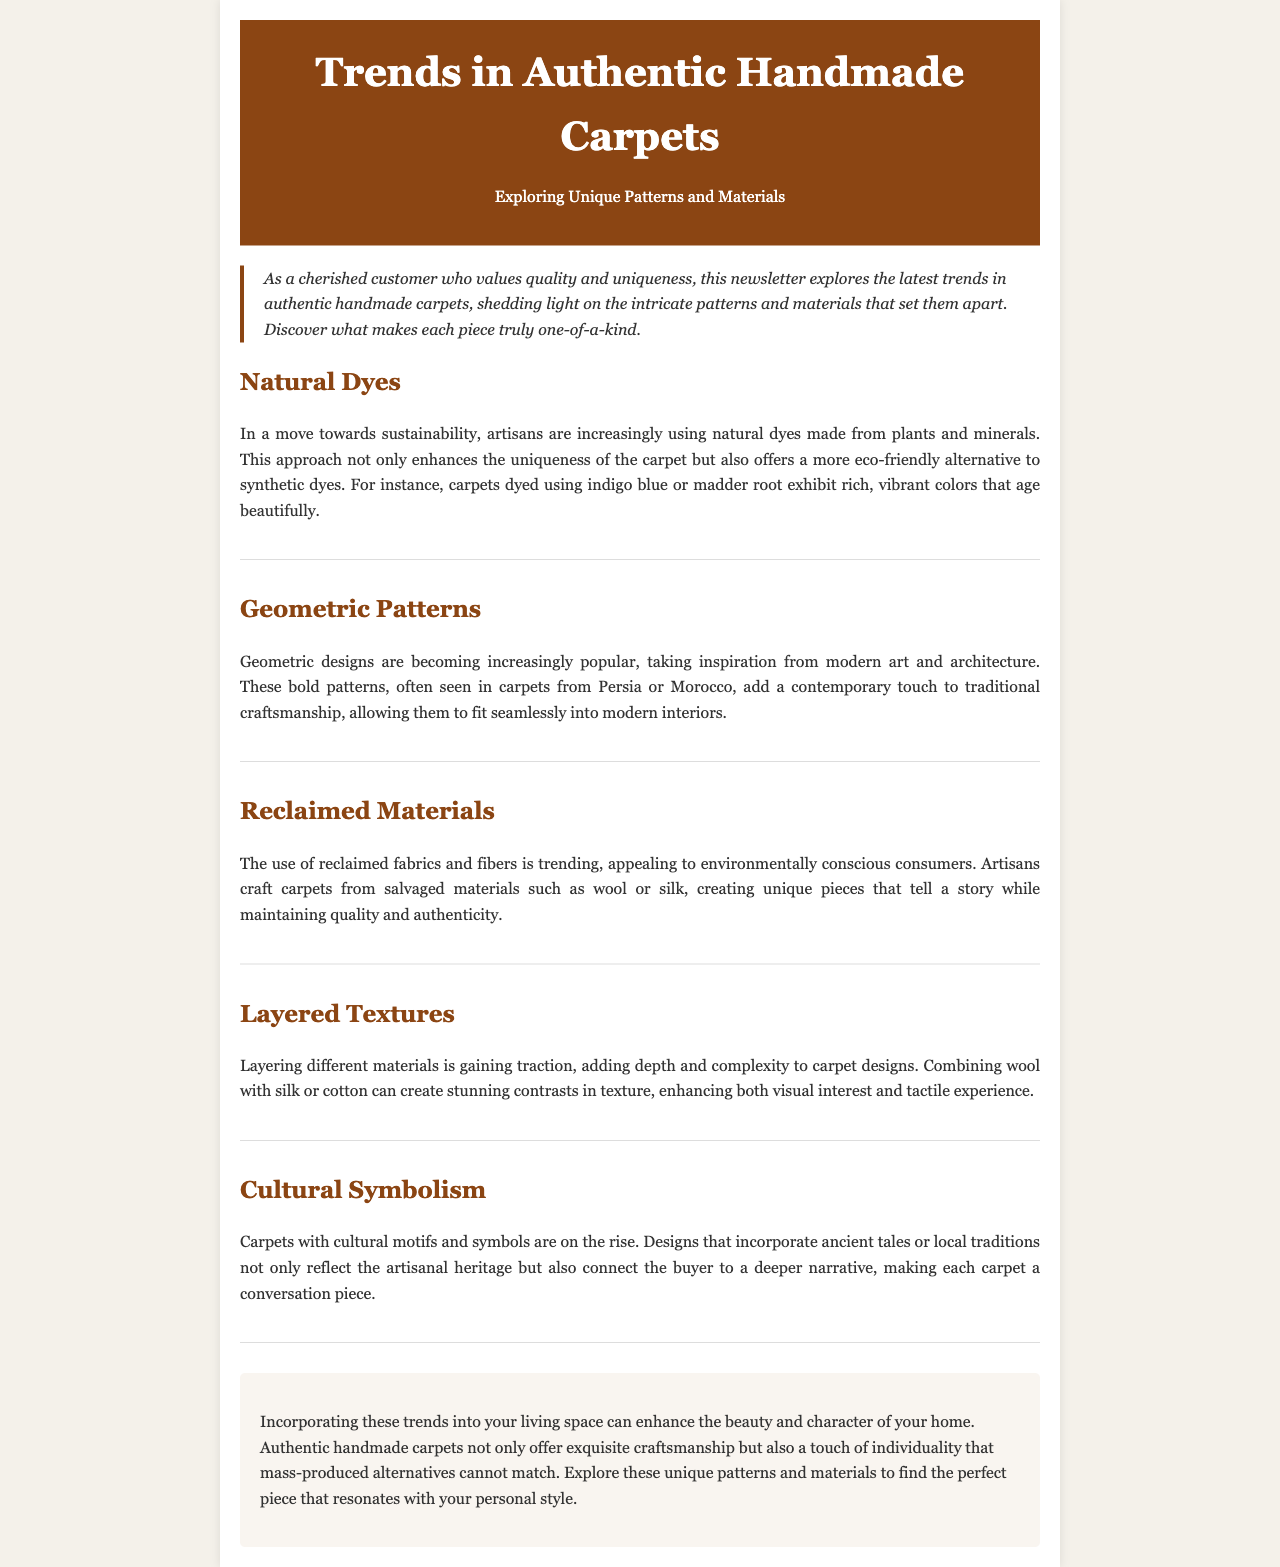what is the title of the newsletter? The title of the newsletter is prominently displayed in the header section of the document.
Answer: Trends in Authentic Handmade Carpets what color dye is mentioned as being used in sustainable carpets? The document refers to a specific natural dye that is increasingly used by artisans.
Answer: indigo blue which type of patterns are highlighted as a trend in handmade carpets? The document discusses the popularity of a certain design style in carpets, reflecting modern influences.
Answer: Geometric patterns what materials are increasingly being reclaimed for carpet production? The document specifies the types of materials that are salvaged for creating unique carpets.
Answer: fabrics and fibers how do layered textures contribute to carpet design? This question requires an understanding of how a specific design approach impacts the overall aesthetic of carpets.
Answer: adding depth and complexity what kind of motifs are rising in popularity according to the newsletter? The document points out a trend that incorporates narrative elements into carpet designs.
Answer: Cultural motifs what is the main focus of the newsletter? The primary topic discussed throughout the newsletter is indicated in the introduction.
Answer: Unique Patterns and Materials how do sustainable practices benefit carpet artisans? This question implies reasoning about the broader impact of the trend mentioned in the document.
Answer: enhances uniqueness what overall impression do handmade carpets leave in a home according to the conclusion? The conclusion of the document encapsulates the value of these carpets in living spaces.
Answer: beauty and character 